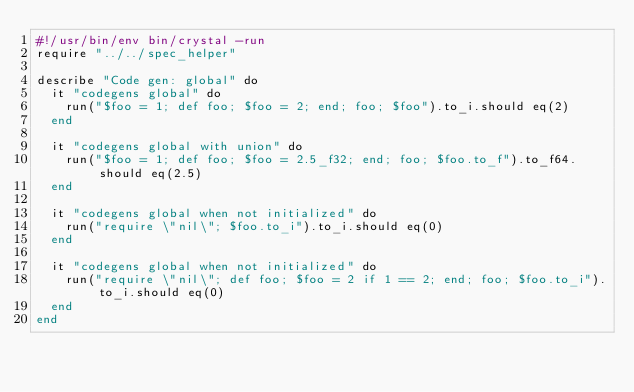<code> <loc_0><loc_0><loc_500><loc_500><_Crystal_>#!/usr/bin/env bin/crystal -run
require "../../spec_helper"

describe "Code gen: global" do
  it "codegens global" do
    run("$foo = 1; def foo; $foo = 2; end; foo; $foo").to_i.should eq(2)
  end

  it "codegens global with union" do
    run("$foo = 1; def foo; $foo = 2.5_f32; end; foo; $foo.to_f").to_f64.should eq(2.5)
  end

  it "codegens global when not initialized" do
    run("require \"nil\"; $foo.to_i").to_i.should eq(0)
  end

  it "codegens global when not initialized" do
    run("require \"nil\"; def foo; $foo = 2 if 1 == 2; end; foo; $foo.to_i").to_i.should eq(0)
  end
end
</code> 